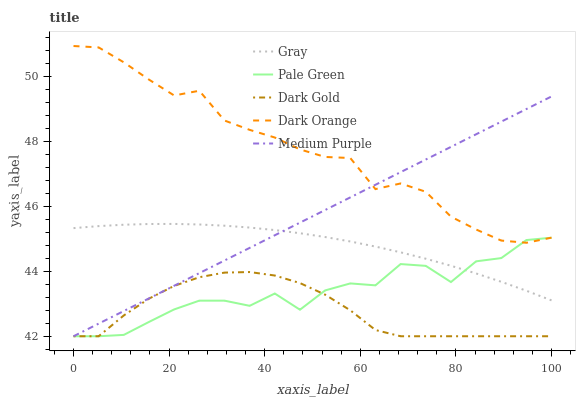Does Dark Gold have the minimum area under the curve?
Answer yes or no. Yes. Does Dark Orange have the maximum area under the curve?
Answer yes or no. Yes. Does Gray have the minimum area under the curve?
Answer yes or no. No. Does Gray have the maximum area under the curve?
Answer yes or no. No. Is Medium Purple the smoothest?
Answer yes or no. Yes. Is Pale Green the roughest?
Answer yes or no. Yes. Is Gray the smoothest?
Answer yes or no. No. Is Gray the roughest?
Answer yes or no. No. Does Medium Purple have the lowest value?
Answer yes or no. Yes. Does Gray have the lowest value?
Answer yes or no. No. Does Dark Orange have the highest value?
Answer yes or no. Yes. Does Gray have the highest value?
Answer yes or no. No. Is Dark Gold less than Gray?
Answer yes or no. Yes. Is Dark Orange greater than Dark Gold?
Answer yes or no. Yes. Does Dark Orange intersect Medium Purple?
Answer yes or no. Yes. Is Dark Orange less than Medium Purple?
Answer yes or no. No. Is Dark Orange greater than Medium Purple?
Answer yes or no. No. Does Dark Gold intersect Gray?
Answer yes or no. No. 